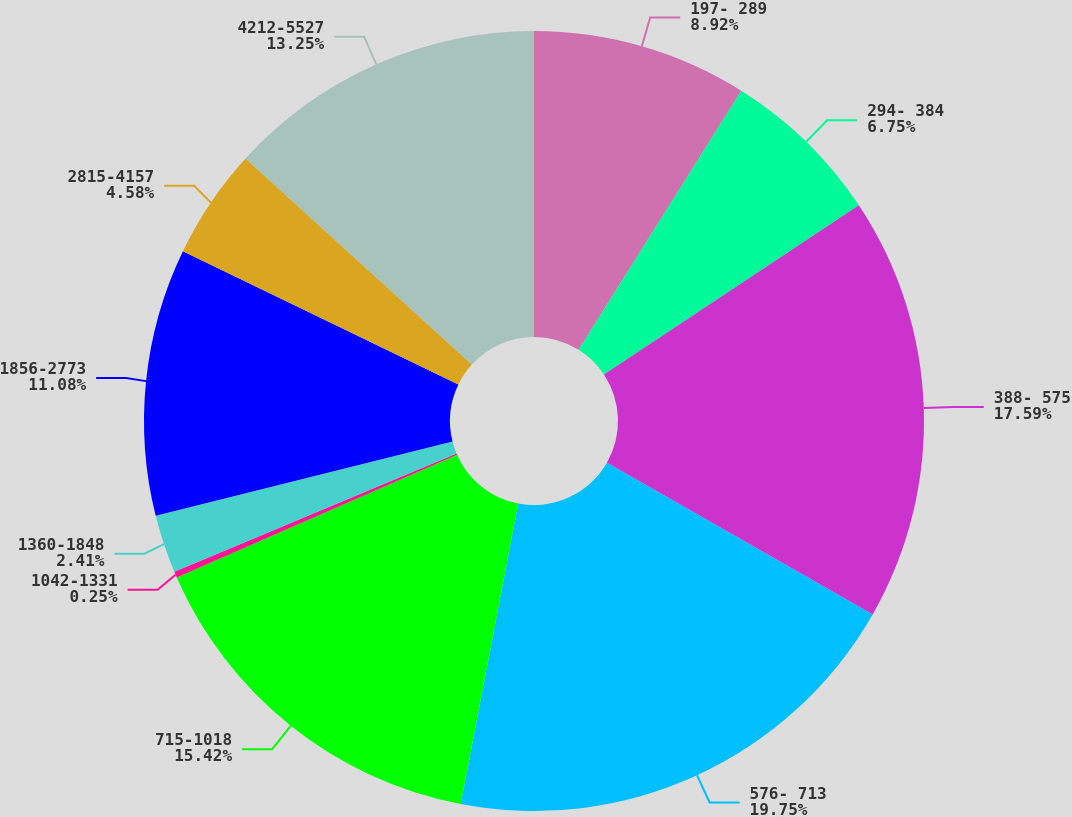Convert chart. <chart><loc_0><loc_0><loc_500><loc_500><pie_chart><fcel>197- 289<fcel>294- 384<fcel>388- 575<fcel>576- 713<fcel>715-1018<fcel>1042-1331<fcel>1360-1848<fcel>1856-2773<fcel>2815-4157<fcel>4212-5527<nl><fcel>8.92%<fcel>6.75%<fcel>17.59%<fcel>19.75%<fcel>15.42%<fcel>0.25%<fcel>2.41%<fcel>11.08%<fcel>4.58%<fcel>13.25%<nl></chart> 